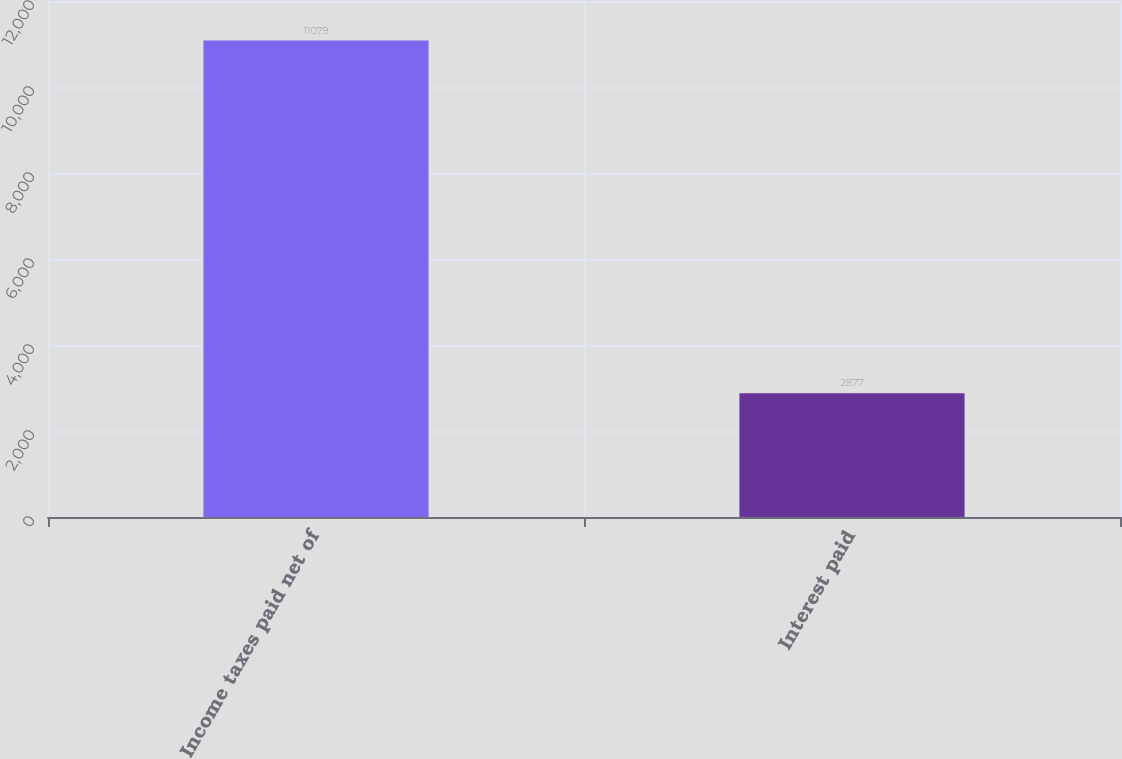Convert chart to OTSL. <chart><loc_0><loc_0><loc_500><loc_500><bar_chart><fcel>Income taxes paid net of<fcel>Interest paid<nl><fcel>11079<fcel>2877<nl></chart> 